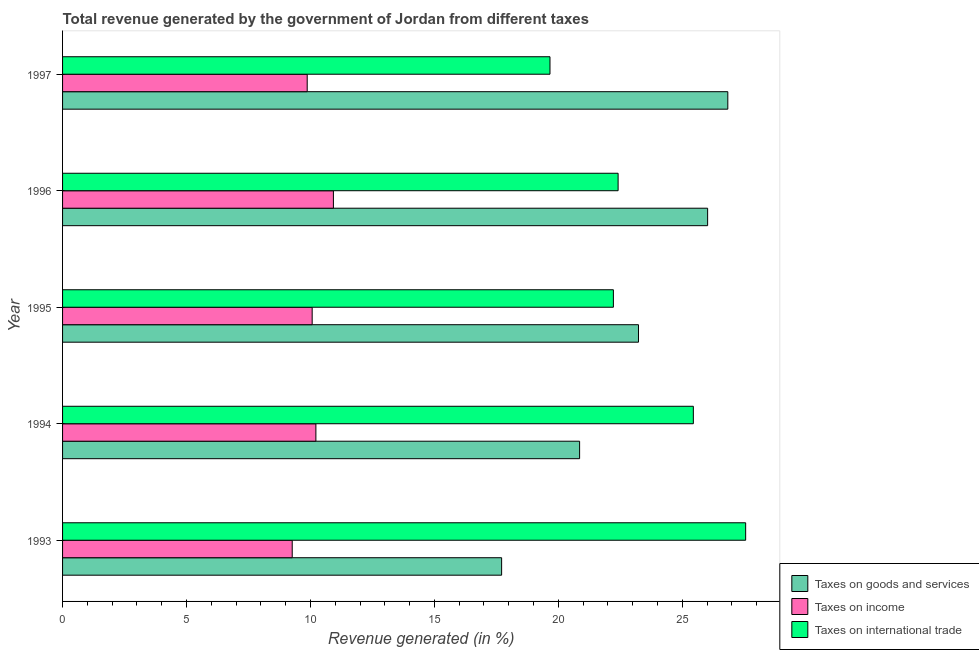How many different coloured bars are there?
Offer a very short reply. 3. How many groups of bars are there?
Provide a succinct answer. 5. Are the number of bars on each tick of the Y-axis equal?
Ensure brevity in your answer.  Yes. How many bars are there on the 2nd tick from the top?
Offer a terse response. 3. How many bars are there on the 5th tick from the bottom?
Give a very brief answer. 3. In how many cases, is the number of bars for a given year not equal to the number of legend labels?
Make the answer very short. 0. What is the percentage of revenue generated by tax on international trade in 1995?
Keep it short and to the point. 22.22. Across all years, what is the maximum percentage of revenue generated by taxes on income?
Your answer should be very brief. 10.93. Across all years, what is the minimum percentage of revenue generated by tax on international trade?
Your answer should be very brief. 19.66. In which year was the percentage of revenue generated by taxes on goods and services minimum?
Your answer should be compact. 1993. What is the total percentage of revenue generated by tax on international trade in the graph?
Your answer should be compact. 117.3. What is the difference between the percentage of revenue generated by taxes on income in 1994 and that in 1996?
Offer a very short reply. -0.71. What is the difference between the percentage of revenue generated by taxes on goods and services in 1997 and the percentage of revenue generated by taxes on income in 1996?
Provide a succinct answer. 15.91. What is the average percentage of revenue generated by taxes on goods and services per year?
Ensure brevity in your answer.  22.93. In the year 1993, what is the difference between the percentage of revenue generated by tax on international trade and percentage of revenue generated by taxes on goods and services?
Give a very brief answer. 9.84. In how many years, is the percentage of revenue generated by taxes on income greater than 15 %?
Provide a short and direct response. 0. What is the ratio of the percentage of revenue generated by taxes on income in 1994 to that in 1997?
Your answer should be compact. 1.04. What is the difference between the highest and the second highest percentage of revenue generated by taxes on goods and services?
Your answer should be compact. 0.81. What is the difference between the highest and the lowest percentage of revenue generated by tax on international trade?
Give a very brief answer. 7.89. In how many years, is the percentage of revenue generated by taxes on goods and services greater than the average percentage of revenue generated by taxes on goods and services taken over all years?
Make the answer very short. 3. Is the sum of the percentage of revenue generated by taxes on income in 1993 and 1996 greater than the maximum percentage of revenue generated by tax on international trade across all years?
Provide a short and direct response. No. What does the 3rd bar from the top in 1993 represents?
Provide a succinct answer. Taxes on goods and services. What does the 2nd bar from the bottom in 1996 represents?
Give a very brief answer. Taxes on income. Does the graph contain grids?
Your response must be concise. No. Where does the legend appear in the graph?
Provide a short and direct response. Bottom right. How many legend labels are there?
Ensure brevity in your answer.  3. What is the title of the graph?
Offer a terse response. Total revenue generated by the government of Jordan from different taxes. What is the label or title of the X-axis?
Make the answer very short. Revenue generated (in %). What is the label or title of the Y-axis?
Provide a succinct answer. Year. What is the Revenue generated (in %) in Taxes on goods and services in 1993?
Offer a very short reply. 17.71. What is the Revenue generated (in %) of Taxes on income in 1993?
Your answer should be compact. 9.26. What is the Revenue generated (in %) in Taxes on international trade in 1993?
Ensure brevity in your answer.  27.56. What is the Revenue generated (in %) of Taxes on goods and services in 1994?
Your response must be concise. 20.86. What is the Revenue generated (in %) of Taxes on income in 1994?
Your response must be concise. 10.22. What is the Revenue generated (in %) of Taxes on international trade in 1994?
Give a very brief answer. 25.45. What is the Revenue generated (in %) in Taxes on goods and services in 1995?
Keep it short and to the point. 23.23. What is the Revenue generated (in %) of Taxes on income in 1995?
Your answer should be very brief. 10.07. What is the Revenue generated (in %) of Taxes on international trade in 1995?
Your answer should be compact. 22.22. What is the Revenue generated (in %) of Taxes on goods and services in 1996?
Your answer should be compact. 26.02. What is the Revenue generated (in %) of Taxes on income in 1996?
Provide a succinct answer. 10.93. What is the Revenue generated (in %) of Taxes on international trade in 1996?
Ensure brevity in your answer.  22.41. What is the Revenue generated (in %) of Taxes on goods and services in 1997?
Your answer should be very brief. 26.84. What is the Revenue generated (in %) in Taxes on income in 1997?
Provide a short and direct response. 9.87. What is the Revenue generated (in %) in Taxes on international trade in 1997?
Ensure brevity in your answer.  19.66. Across all years, what is the maximum Revenue generated (in %) in Taxes on goods and services?
Offer a terse response. 26.84. Across all years, what is the maximum Revenue generated (in %) of Taxes on income?
Your response must be concise. 10.93. Across all years, what is the maximum Revenue generated (in %) in Taxes on international trade?
Your answer should be very brief. 27.56. Across all years, what is the minimum Revenue generated (in %) of Taxes on goods and services?
Offer a very short reply. 17.71. Across all years, what is the minimum Revenue generated (in %) of Taxes on income?
Your answer should be compact. 9.26. Across all years, what is the minimum Revenue generated (in %) of Taxes on international trade?
Provide a short and direct response. 19.66. What is the total Revenue generated (in %) of Taxes on goods and services in the graph?
Keep it short and to the point. 114.66. What is the total Revenue generated (in %) in Taxes on income in the graph?
Offer a very short reply. 50.35. What is the total Revenue generated (in %) in Taxes on international trade in the graph?
Your answer should be compact. 117.3. What is the difference between the Revenue generated (in %) in Taxes on goods and services in 1993 and that in 1994?
Provide a short and direct response. -3.15. What is the difference between the Revenue generated (in %) of Taxes on income in 1993 and that in 1994?
Ensure brevity in your answer.  -0.95. What is the difference between the Revenue generated (in %) in Taxes on international trade in 1993 and that in 1994?
Your answer should be compact. 2.11. What is the difference between the Revenue generated (in %) of Taxes on goods and services in 1993 and that in 1995?
Offer a very short reply. -5.52. What is the difference between the Revenue generated (in %) in Taxes on income in 1993 and that in 1995?
Your answer should be very brief. -0.8. What is the difference between the Revenue generated (in %) in Taxes on international trade in 1993 and that in 1995?
Give a very brief answer. 5.34. What is the difference between the Revenue generated (in %) in Taxes on goods and services in 1993 and that in 1996?
Your response must be concise. -8.31. What is the difference between the Revenue generated (in %) in Taxes on income in 1993 and that in 1996?
Provide a short and direct response. -1.66. What is the difference between the Revenue generated (in %) in Taxes on international trade in 1993 and that in 1996?
Your answer should be compact. 5.14. What is the difference between the Revenue generated (in %) of Taxes on goods and services in 1993 and that in 1997?
Provide a succinct answer. -9.12. What is the difference between the Revenue generated (in %) in Taxes on income in 1993 and that in 1997?
Keep it short and to the point. -0.6. What is the difference between the Revenue generated (in %) of Taxes on international trade in 1993 and that in 1997?
Your response must be concise. 7.89. What is the difference between the Revenue generated (in %) of Taxes on goods and services in 1994 and that in 1995?
Provide a succinct answer. -2.37. What is the difference between the Revenue generated (in %) of Taxes on income in 1994 and that in 1995?
Offer a terse response. 0.15. What is the difference between the Revenue generated (in %) in Taxes on international trade in 1994 and that in 1995?
Ensure brevity in your answer.  3.23. What is the difference between the Revenue generated (in %) in Taxes on goods and services in 1994 and that in 1996?
Your response must be concise. -5.16. What is the difference between the Revenue generated (in %) of Taxes on income in 1994 and that in 1996?
Make the answer very short. -0.71. What is the difference between the Revenue generated (in %) in Taxes on international trade in 1994 and that in 1996?
Provide a succinct answer. 3.04. What is the difference between the Revenue generated (in %) of Taxes on goods and services in 1994 and that in 1997?
Provide a succinct answer. -5.98. What is the difference between the Revenue generated (in %) in Taxes on income in 1994 and that in 1997?
Make the answer very short. 0.35. What is the difference between the Revenue generated (in %) of Taxes on international trade in 1994 and that in 1997?
Provide a short and direct response. 5.78. What is the difference between the Revenue generated (in %) in Taxes on goods and services in 1995 and that in 1996?
Keep it short and to the point. -2.79. What is the difference between the Revenue generated (in %) of Taxes on income in 1995 and that in 1996?
Offer a terse response. -0.86. What is the difference between the Revenue generated (in %) of Taxes on international trade in 1995 and that in 1996?
Keep it short and to the point. -0.19. What is the difference between the Revenue generated (in %) in Taxes on goods and services in 1995 and that in 1997?
Your answer should be very brief. -3.6. What is the difference between the Revenue generated (in %) of Taxes on income in 1995 and that in 1997?
Ensure brevity in your answer.  0.2. What is the difference between the Revenue generated (in %) of Taxes on international trade in 1995 and that in 1997?
Provide a short and direct response. 2.56. What is the difference between the Revenue generated (in %) in Taxes on goods and services in 1996 and that in 1997?
Make the answer very short. -0.81. What is the difference between the Revenue generated (in %) of Taxes on income in 1996 and that in 1997?
Ensure brevity in your answer.  1.06. What is the difference between the Revenue generated (in %) of Taxes on international trade in 1996 and that in 1997?
Your response must be concise. 2.75. What is the difference between the Revenue generated (in %) in Taxes on goods and services in 1993 and the Revenue generated (in %) in Taxes on income in 1994?
Give a very brief answer. 7.49. What is the difference between the Revenue generated (in %) of Taxes on goods and services in 1993 and the Revenue generated (in %) of Taxes on international trade in 1994?
Give a very brief answer. -7.73. What is the difference between the Revenue generated (in %) in Taxes on income in 1993 and the Revenue generated (in %) in Taxes on international trade in 1994?
Give a very brief answer. -16.18. What is the difference between the Revenue generated (in %) of Taxes on goods and services in 1993 and the Revenue generated (in %) of Taxes on income in 1995?
Ensure brevity in your answer.  7.64. What is the difference between the Revenue generated (in %) in Taxes on goods and services in 1993 and the Revenue generated (in %) in Taxes on international trade in 1995?
Offer a very short reply. -4.51. What is the difference between the Revenue generated (in %) of Taxes on income in 1993 and the Revenue generated (in %) of Taxes on international trade in 1995?
Your response must be concise. -12.96. What is the difference between the Revenue generated (in %) of Taxes on goods and services in 1993 and the Revenue generated (in %) of Taxes on income in 1996?
Offer a very short reply. 6.79. What is the difference between the Revenue generated (in %) of Taxes on goods and services in 1993 and the Revenue generated (in %) of Taxes on international trade in 1996?
Your answer should be compact. -4.7. What is the difference between the Revenue generated (in %) of Taxes on income in 1993 and the Revenue generated (in %) of Taxes on international trade in 1996?
Offer a terse response. -13.15. What is the difference between the Revenue generated (in %) in Taxes on goods and services in 1993 and the Revenue generated (in %) in Taxes on income in 1997?
Keep it short and to the point. 7.84. What is the difference between the Revenue generated (in %) of Taxes on goods and services in 1993 and the Revenue generated (in %) of Taxes on international trade in 1997?
Your answer should be compact. -1.95. What is the difference between the Revenue generated (in %) in Taxes on income in 1993 and the Revenue generated (in %) in Taxes on international trade in 1997?
Give a very brief answer. -10.4. What is the difference between the Revenue generated (in %) of Taxes on goods and services in 1994 and the Revenue generated (in %) of Taxes on income in 1995?
Give a very brief answer. 10.79. What is the difference between the Revenue generated (in %) of Taxes on goods and services in 1994 and the Revenue generated (in %) of Taxes on international trade in 1995?
Provide a succinct answer. -1.36. What is the difference between the Revenue generated (in %) of Taxes on income in 1994 and the Revenue generated (in %) of Taxes on international trade in 1995?
Your answer should be compact. -12. What is the difference between the Revenue generated (in %) in Taxes on goods and services in 1994 and the Revenue generated (in %) in Taxes on income in 1996?
Give a very brief answer. 9.93. What is the difference between the Revenue generated (in %) in Taxes on goods and services in 1994 and the Revenue generated (in %) in Taxes on international trade in 1996?
Your answer should be very brief. -1.55. What is the difference between the Revenue generated (in %) of Taxes on income in 1994 and the Revenue generated (in %) of Taxes on international trade in 1996?
Your response must be concise. -12.19. What is the difference between the Revenue generated (in %) of Taxes on goods and services in 1994 and the Revenue generated (in %) of Taxes on income in 1997?
Your response must be concise. 10.99. What is the difference between the Revenue generated (in %) of Taxes on goods and services in 1994 and the Revenue generated (in %) of Taxes on international trade in 1997?
Give a very brief answer. 1.19. What is the difference between the Revenue generated (in %) in Taxes on income in 1994 and the Revenue generated (in %) in Taxes on international trade in 1997?
Your answer should be compact. -9.44. What is the difference between the Revenue generated (in %) in Taxes on goods and services in 1995 and the Revenue generated (in %) in Taxes on income in 1996?
Your answer should be very brief. 12.31. What is the difference between the Revenue generated (in %) in Taxes on goods and services in 1995 and the Revenue generated (in %) in Taxes on international trade in 1996?
Offer a terse response. 0.82. What is the difference between the Revenue generated (in %) of Taxes on income in 1995 and the Revenue generated (in %) of Taxes on international trade in 1996?
Keep it short and to the point. -12.34. What is the difference between the Revenue generated (in %) in Taxes on goods and services in 1995 and the Revenue generated (in %) in Taxes on income in 1997?
Provide a succinct answer. 13.36. What is the difference between the Revenue generated (in %) in Taxes on goods and services in 1995 and the Revenue generated (in %) in Taxes on international trade in 1997?
Offer a terse response. 3.57. What is the difference between the Revenue generated (in %) in Taxes on income in 1995 and the Revenue generated (in %) in Taxes on international trade in 1997?
Your answer should be compact. -9.59. What is the difference between the Revenue generated (in %) of Taxes on goods and services in 1996 and the Revenue generated (in %) of Taxes on income in 1997?
Offer a very short reply. 16.15. What is the difference between the Revenue generated (in %) in Taxes on goods and services in 1996 and the Revenue generated (in %) in Taxes on international trade in 1997?
Your response must be concise. 6.36. What is the difference between the Revenue generated (in %) of Taxes on income in 1996 and the Revenue generated (in %) of Taxes on international trade in 1997?
Offer a very short reply. -8.74. What is the average Revenue generated (in %) of Taxes on goods and services per year?
Ensure brevity in your answer.  22.93. What is the average Revenue generated (in %) of Taxes on income per year?
Provide a short and direct response. 10.07. What is the average Revenue generated (in %) of Taxes on international trade per year?
Ensure brevity in your answer.  23.46. In the year 1993, what is the difference between the Revenue generated (in %) of Taxes on goods and services and Revenue generated (in %) of Taxes on income?
Make the answer very short. 8.45. In the year 1993, what is the difference between the Revenue generated (in %) of Taxes on goods and services and Revenue generated (in %) of Taxes on international trade?
Your answer should be compact. -9.84. In the year 1993, what is the difference between the Revenue generated (in %) in Taxes on income and Revenue generated (in %) in Taxes on international trade?
Provide a succinct answer. -18.29. In the year 1994, what is the difference between the Revenue generated (in %) of Taxes on goods and services and Revenue generated (in %) of Taxes on income?
Offer a terse response. 10.64. In the year 1994, what is the difference between the Revenue generated (in %) in Taxes on goods and services and Revenue generated (in %) in Taxes on international trade?
Provide a succinct answer. -4.59. In the year 1994, what is the difference between the Revenue generated (in %) of Taxes on income and Revenue generated (in %) of Taxes on international trade?
Provide a succinct answer. -15.23. In the year 1995, what is the difference between the Revenue generated (in %) in Taxes on goods and services and Revenue generated (in %) in Taxes on income?
Your answer should be compact. 13.16. In the year 1995, what is the difference between the Revenue generated (in %) of Taxes on income and Revenue generated (in %) of Taxes on international trade?
Your response must be concise. -12.15. In the year 1996, what is the difference between the Revenue generated (in %) in Taxes on goods and services and Revenue generated (in %) in Taxes on income?
Give a very brief answer. 15.1. In the year 1996, what is the difference between the Revenue generated (in %) of Taxes on goods and services and Revenue generated (in %) of Taxes on international trade?
Make the answer very short. 3.61. In the year 1996, what is the difference between the Revenue generated (in %) of Taxes on income and Revenue generated (in %) of Taxes on international trade?
Give a very brief answer. -11.48. In the year 1997, what is the difference between the Revenue generated (in %) in Taxes on goods and services and Revenue generated (in %) in Taxes on income?
Provide a succinct answer. 16.97. In the year 1997, what is the difference between the Revenue generated (in %) of Taxes on goods and services and Revenue generated (in %) of Taxes on international trade?
Your answer should be compact. 7.17. In the year 1997, what is the difference between the Revenue generated (in %) of Taxes on income and Revenue generated (in %) of Taxes on international trade?
Provide a succinct answer. -9.79. What is the ratio of the Revenue generated (in %) in Taxes on goods and services in 1993 to that in 1994?
Your response must be concise. 0.85. What is the ratio of the Revenue generated (in %) in Taxes on income in 1993 to that in 1994?
Offer a very short reply. 0.91. What is the ratio of the Revenue generated (in %) of Taxes on international trade in 1993 to that in 1994?
Keep it short and to the point. 1.08. What is the ratio of the Revenue generated (in %) in Taxes on goods and services in 1993 to that in 1995?
Offer a terse response. 0.76. What is the ratio of the Revenue generated (in %) of Taxes on income in 1993 to that in 1995?
Provide a short and direct response. 0.92. What is the ratio of the Revenue generated (in %) in Taxes on international trade in 1993 to that in 1995?
Your answer should be very brief. 1.24. What is the ratio of the Revenue generated (in %) of Taxes on goods and services in 1993 to that in 1996?
Make the answer very short. 0.68. What is the ratio of the Revenue generated (in %) in Taxes on income in 1993 to that in 1996?
Give a very brief answer. 0.85. What is the ratio of the Revenue generated (in %) in Taxes on international trade in 1993 to that in 1996?
Give a very brief answer. 1.23. What is the ratio of the Revenue generated (in %) in Taxes on goods and services in 1993 to that in 1997?
Your response must be concise. 0.66. What is the ratio of the Revenue generated (in %) of Taxes on income in 1993 to that in 1997?
Provide a short and direct response. 0.94. What is the ratio of the Revenue generated (in %) of Taxes on international trade in 1993 to that in 1997?
Give a very brief answer. 1.4. What is the ratio of the Revenue generated (in %) in Taxes on goods and services in 1994 to that in 1995?
Make the answer very short. 0.9. What is the ratio of the Revenue generated (in %) of Taxes on income in 1994 to that in 1995?
Ensure brevity in your answer.  1.01. What is the ratio of the Revenue generated (in %) in Taxes on international trade in 1994 to that in 1995?
Keep it short and to the point. 1.15. What is the ratio of the Revenue generated (in %) in Taxes on goods and services in 1994 to that in 1996?
Make the answer very short. 0.8. What is the ratio of the Revenue generated (in %) in Taxes on income in 1994 to that in 1996?
Your answer should be very brief. 0.94. What is the ratio of the Revenue generated (in %) of Taxes on international trade in 1994 to that in 1996?
Provide a short and direct response. 1.14. What is the ratio of the Revenue generated (in %) in Taxes on goods and services in 1994 to that in 1997?
Your response must be concise. 0.78. What is the ratio of the Revenue generated (in %) in Taxes on income in 1994 to that in 1997?
Provide a short and direct response. 1.04. What is the ratio of the Revenue generated (in %) in Taxes on international trade in 1994 to that in 1997?
Make the answer very short. 1.29. What is the ratio of the Revenue generated (in %) in Taxes on goods and services in 1995 to that in 1996?
Your response must be concise. 0.89. What is the ratio of the Revenue generated (in %) in Taxes on income in 1995 to that in 1996?
Ensure brevity in your answer.  0.92. What is the ratio of the Revenue generated (in %) of Taxes on goods and services in 1995 to that in 1997?
Your answer should be very brief. 0.87. What is the ratio of the Revenue generated (in %) in Taxes on income in 1995 to that in 1997?
Offer a terse response. 1.02. What is the ratio of the Revenue generated (in %) in Taxes on international trade in 1995 to that in 1997?
Keep it short and to the point. 1.13. What is the ratio of the Revenue generated (in %) in Taxes on goods and services in 1996 to that in 1997?
Provide a succinct answer. 0.97. What is the ratio of the Revenue generated (in %) in Taxes on income in 1996 to that in 1997?
Make the answer very short. 1.11. What is the ratio of the Revenue generated (in %) of Taxes on international trade in 1996 to that in 1997?
Offer a terse response. 1.14. What is the difference between the highest and the second highest Revenue generated (in %) in Taxes on goods and services?
Keep it short and to the point. 0.81. What is the difference between the highest and the second highest Revenue generated (in %) of Taxes on income?
Give a very brief answer. 0.71. What is the difference between the highest and the second highest Revenue generated (in %) in Taxes on international trade?
Provide a short and direct response. 2.11. What is the difference between the highest and the lowest Revenue generated (in %) in Taxes on goods and services?
Make the answer very short. 9.12. What is the difference between the highest and the lowest Revenue generated (in %) of Taxes on income?
Offer a terse response. 1.66. What is the difference between the highest and the lowest Revenue generated (in %) of Taxes on international trade?
Keep it short and to the point. 7.89. 